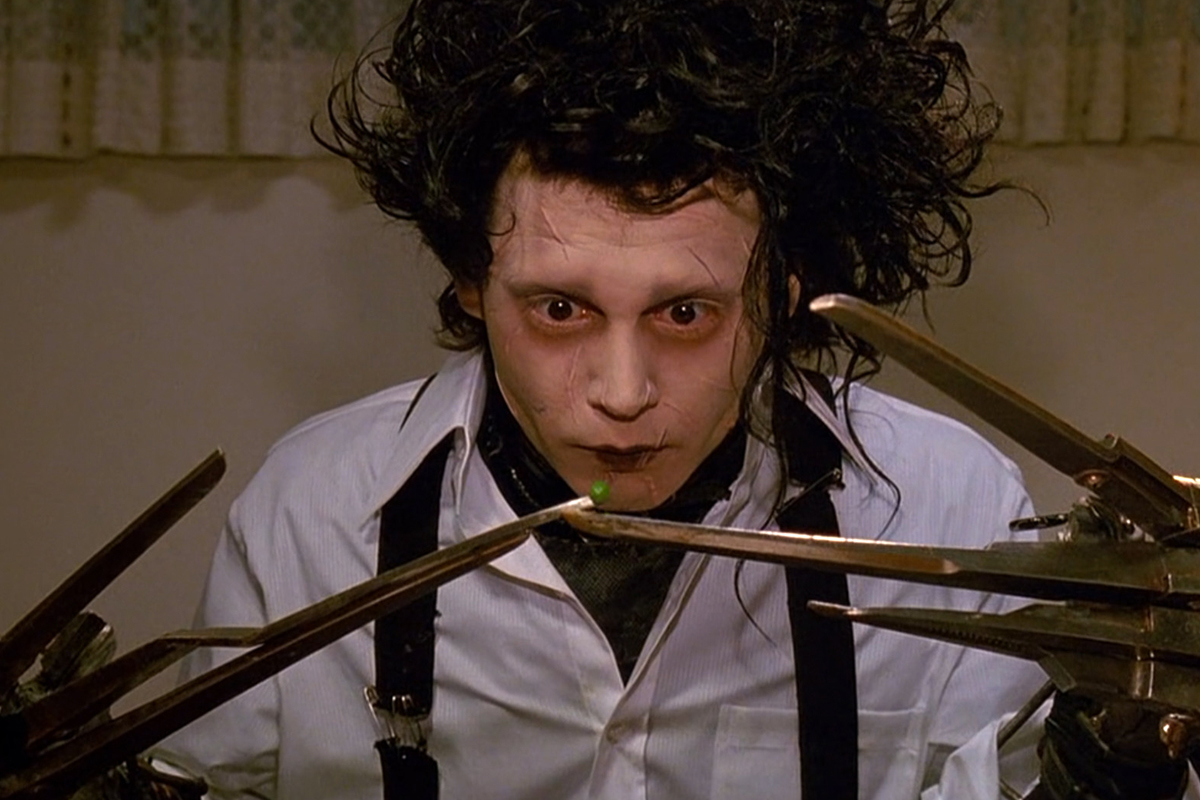What might be the emotional impact of this scene on a viewer? This scene likely evokes a deep sense of empathy and sadness. Edward's sorrowful eyes and the defensive, yet vulnerable placement of his scissorhands close to his face, may stir feelings of pity and compassion. The viewer might also feel a sense of injustice, seeing someone so gentle yet so misunderstood, trapped by his own uniqueness. This emotional impact is central to connecting audiences with Edward’s character and the broader narrative conflicts he faces. 